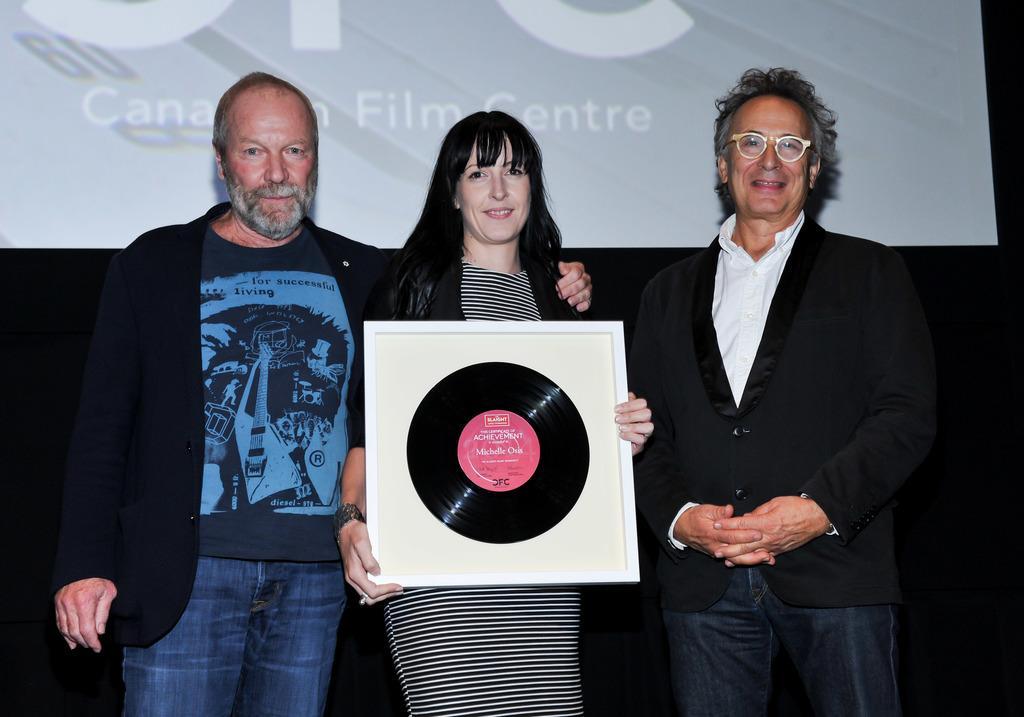Please provide a concise description of this image. In this picture we can see three people and one woman is holding an object and in the background we can see a projector screen. 